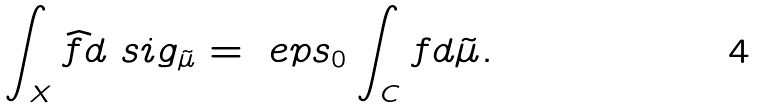<formula> <loc_0><loc_0><loc_500><loc_500>\int _ { X } \widehat { f } d \ s i g _ { \tilde { \mu } } = \ e p s _ { 0 } \int _ { C } f d \tilde { \mu } .</formula> 